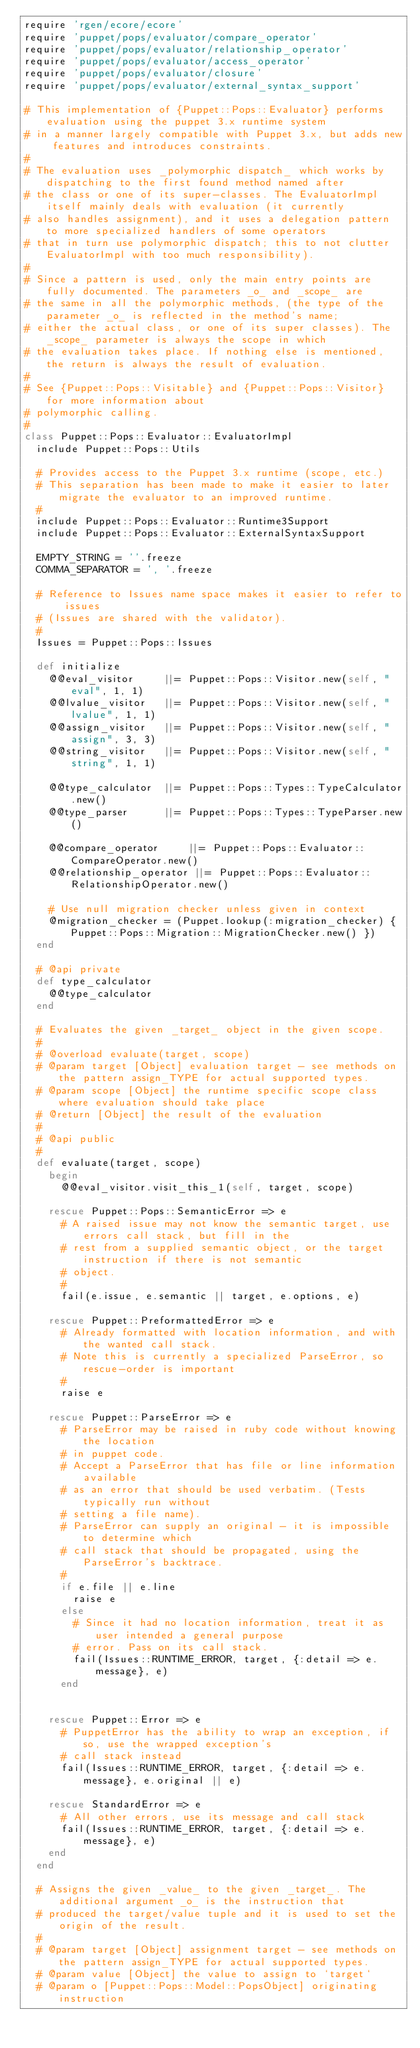<code> <loc_0><loc_0><loc_500><loc_500><_Ruby_>require 'rgen/ecore/ecore'
require 'puppet/pops/evaluator/compare_operator'
require 'puppet/pops/evaluator/relationship_operator'
require 'puppet/pops/evaluator/access_operator'
require 'puppet/pops/evaluator/closure'
require 'puppet/pops/evaluator/external_syntax_support'

# This implementation of {Puppet::Pops::Evaluator} performs evaluation using the puppet 3.x runtime system
# in a manner largely compatible with Puppet 3.x, but adds new features and introduces constraints.
#
# The evaluation uses _polymorphic dispatch_ which works by dispatching to the first found method named after
# the class or one of its super-classes. The EvaluatorImpl itself mainly deals with evaluation (it currently
# also handles assignment), and it uses a delegation pattern to more specialized handlers of some operators
# that in turn use polymorphic dispatch; this to not clutter EvaluatorImpl with too much responsibility).
#
# Since a pattern is used, only the main entry points are fully documented. The parameters _o_ and _scope_ are
# the same in all the polymorphic methods, (the type of the parameter _o_ is reflected in the method's name;
# either the actual class, or one of its super classes). The _scope_ parameter is always the scope in which
# the evaluation takes place. If nothing else is mentioned, the return is always the result of evaluation.
#
# See {Puppet::Pops::Visitable} and {Puppet::Pops::Visitor} for more information about
# polymorphic calling.
#
class Puppet::Pops::Evaluator::EvaluatorImpl
  include Puppet::Pops::Utils

  # Provides access to the Puppet 3.x runtime (scope, etc.)
  # This separation has been made to make it easier to later migrate the evaluator to an improved runtime.
  #
  include Puppet::Pops::Evaluator::Runtime3Support
  include Puppet::Pops::Evaluator::ExternalSyntaxSupport

  EMPTY_STRING = ''.freeze
  COMMA_SEPARATOR = ', '.freeze

  # Reference to Issues name space makes it easier to refer to issues
  # (Issues are shared with the validator).
  #
  Issues = Puppet::Pops::Issues

  def initialize
    @@eval_visitor     ||= Puppet::Pops::Visitor.new(self, "eval", 1, 1)
    @@lvalue_visitor   ||= Puppet::Pops::Visitor.new(self, "lvalue", 1, 1)
    @@assign_visitor   ||= Puppet::Pops::Visitor.new(self, "assign", 3, 3)
    @@string_visitor   ||= Puppet::Pops::Visitor.new(self, "string", 1, 1)

    @@type_calculator  ||= Puppet::Pops::Types::TypeCalculator.new()
    @@type_parser      ||= Puppet::Pops::Types::TypeParser.new()

    @@compare_operator     ||= Puppet::Pops::Evaluator::CompareOperator.new()
    @@relationship_operator ||= Puppet::Pops::Evaluator::RelationshipOperator.new()

    # Use null migration checker unless given in context
    @migration_checker = (Puppet.lookup(:migration_checker) { Puppet::Pops::Migration::MigrationChecker.new() })
  end

  # @api private
  def type_calculator
    @@type_calculator
  end

  # Evaluates the given _target_ object in the given scope.
  #
  # @overload evaluate(target, scope)
  # @param target [Object] evaluation target - see methods on the pattern assign_TYPE for actual supported types.
  # @param scope [Object] the runtime specific scope class where evaluation should take place
  # @return [Object] the result of the evaluation
  #
  # @api public
  #
  def evaluate(target, scope)
    begin
      @@eval_visitor.visit_this_1(self, target, scope)

    rescue Puppet::Pops::SemanticError => e
      # A raised issue may not know the semantic target, use errors call stack, but fill in the 
      # rest from a supplied semantic object, or the target instruction if there is not semantic
      # object.
      #
      fail(e.issue, e.semantic || target, e.options, e)

    rescue Puppet::PreformattedError => e
      # Already formatted with location information, and with the wanted call stack.
      # Note this is currently a specialized ParseError, so rescue-order is important
      #
      raise e

    rescue Puppet::ParseError => e
      # ParseError may be raised in ruby code without knowing the location
      # in puppet code.
      # Accept a ParseError that has file or line information available
      # as an error that should be used verbatim. (Tests typically run without
      # setting a file name).
      # ParseError can supply an original - it is impossible to determine which
      # call stack that should be propagated, using the ParseError's backtrace.
      #
      if e.file || e.line
        raise e
      else
        # Since it had no location information, treat it as user intended a general purpose
        # error. Pass on its call stack.
        fail(Issues::RUNTIME_ERROR, target, {:detail => e.message}, e)
      end


    rescue Puppet::Error => e
      # PuppetError has the ability to wrap an exception, if so, use the wrapped exception's
      # call stack instead
      fail(Issues::RUNTIME_ERROR, target, {:detail => e.message}, e.original || e)

    rescue StandardError => e
      # All other errors, use its message and call stack
      fail(Issues::RUNTIME_ERROR, target, {:detail => e.message}, e)
    end
  end

  # Assigns the given _value_ to the given _target_. The additional argument _o_ is the instruction that
  # produced the target/value tuple and it is used to set the origin of the result.
  #
  # @param target [Object] assignment target - see methods on the pattern assign_TYPE for actual supported types.
  # @param value [Object] the value to assign to `target`
  # @param o [Puppet::Pops::Model::PopsObject] originating instruction</code> 